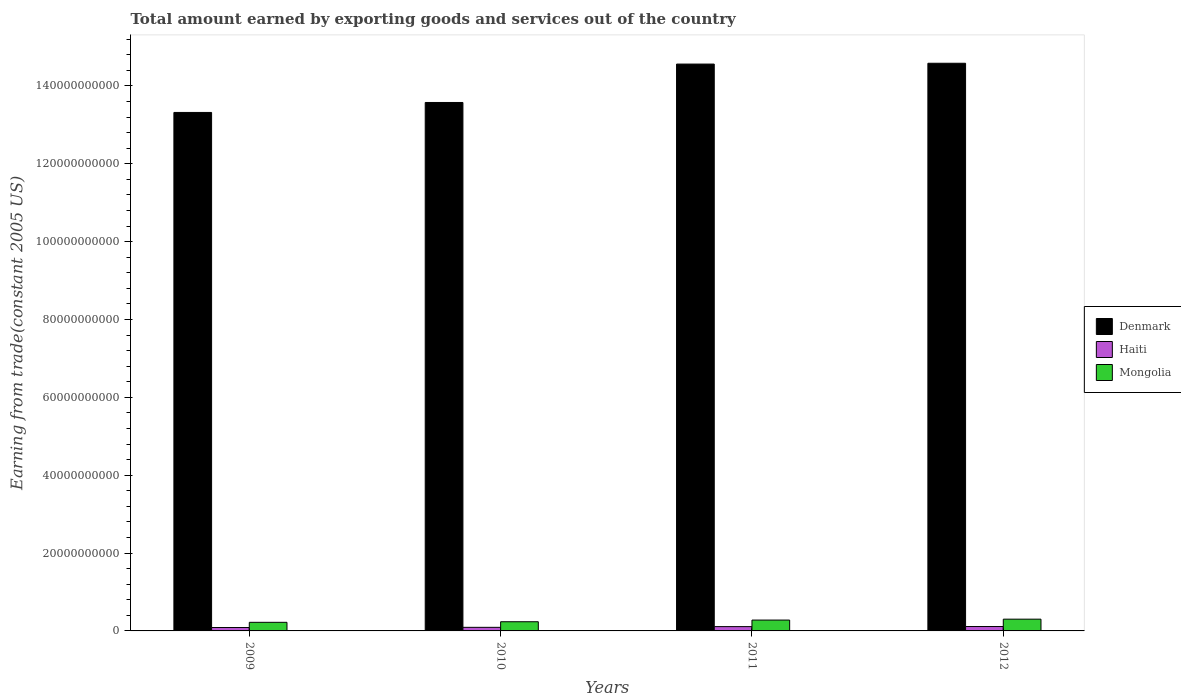How many different coloured bars are there?
Your answer should be compact. 3. Are the number of bars on each tick of the X-axis equal?
Your response must be concise. Yes. How many bars are there on the 4th tick from the right?
Keep it short and to the point. 3. What is the total amount earned by exporting goods and services in Denmark in 2012?
Keep it short and to the point. 1.46e+11. Across all years, what is the maximum total amount earned by exporting goods and services in Mongolia?
Offer a very short reply. 3.02e+09. Across all years, what is the minimum total amount earned by exporting goods and services in Mongolia?
Provide a succinct answer. 2.21e+09. What is the total total amount earned by exporting goods and services in Mongolia in the graph?
Ensure brevity in your answer.  1.04e+1. What is the difference between the total amount earned by exporting goods and services in Haiti in 2010 and that in 2012?
Make the answer very short. -2.10e+08. What is the difference between the total amount earned by exporting goods and services in Mongolia in 2011 and the total amount earned by exporting goods and services in Denmark in 2010?
Keep it short and to the point. -1.33e+11. What is the average total amount earned by exporting goods and services in Mongolia per year?
Make the answer very short. 2.59e+09. In the year 2012, what is the difference between the total amount earned by exporting goods and services in Denmark and total amount earned by exporting goods and services in Haiti?
Keep it short and to the point. 1.45e+11. What is the ratio of the total amount earned by exporting goods and services in Denmark in 2010 to that in 2012?
Your answer should be compact. 0.93. What is the difference between the highest and the second highest total amount earned by exporting goods and services in Haiti?
Your answer should be compact. 2.32e+07. What is the difference between the highest and the lowest total amount earned by exporting goods and services in Haiti?
Your response must be concise. 2.55e+08. What does the 2nd bar from the left in 2009 represents?
Make the answer very short. Haiti. What does the 2nd bar from the right in 2010 represents?
Your answer should be very brief. Haiti. Is it the case that in every year, the sum of the total amount earned by exporting goods and services in Denmark and total amount earned by exporting goods and services in Mongolia is greater than the total amount earned by exporting goods and services in Haiti?
Your answer should be compact. Yes. What is the difference between two consecutive major ticks on the Y-axis?
Ensure brevity in your answer.  2.00e+1. Are the values on the major ticks of Y-axis written in scientific E-notation?
Give a very brief answer. No. How many legend labels are there?
Make the answer very short. 3. How are the legend labels stacked?
Offer a very short reply. Vertical. What is the title of the graph?
Offer a very short reply. Total amount earned by exporting goods and services out of the country. Does "Paraguay" appear as one of the legend labels in the graph?
Your answer should be very brief. No. What is the label or title of the Y-axis?
Ensure brevity in your answer.  Earning from trade(constant 2005 US). What is the Earning from trade(constant 2005 US) in Denmark in 2009?
Your answer should be very brief. 1.33e+11. What is the Earning from trade(constant 2005 US) in Haiti in 2009?
Provide a succinct answer. 8.75e+08. What is the Earning from trade(constant 2005 US) of Mongolia in 2009?
Your response must be concise. 2.21e+09. What is the Earning from trade(constant 2005 US) in Denmark in 2010?
Provide a short and direct response. 1.36e+11. What is the Earning from trade(constant 2005 US) in Haiti in 2010?
Ensure brevity in your answer.  9.20e+08. What is the Earning from trade(constant 2005 US) in Mongolia in 2010?
Your answer should be compact. 2.36e+09. What is the Earning from trade(constant 2005 US) in Denmark in 2011?
Your answer should be compact. 1.46e+11. What is the Earning from trade(constant 2005 US) of Haiti in 2011?
Provide a short and direct response. 1.11e+09. What is the Earning from trade(constant 2005 US) in Mongolia in 2011?
Offer a very short reply. 2.79e+09. What is the Earning from trade(constant 2005 US) in Denmark in 2012?
Give a very brief answer. 1.46e+11. What is the Earning from trade(constant 2005 US) in Haiti in 2012?
Keep it short and to the point. 1.13e+09. What is the Earning from trade(constant 2005 US) of Mongolia in 2012?
Provide a succinct answer. 3.02e+09. Across all years, what is the maximum Earning from trade(constant 2005 US) of Denmark?
Offer a terse response. 1.46e+11. Across all years, what is the maximum Earning from trade(constant 2005 US) of Haiti?
Give a very brief answer. 1.13e+09. Across all years, what is the maximum Earning from trade(constant 2005 US) of Mongolia?
Provide a short and direct response. 3.02e+09. Across all years, what is the minimum Earning from trade(constant 2005 US) in Denmark?
Offer a terse response. 1.33e+11. Across all years, what is the minimum Earning from trade(constant 2005 US) of Haiti?
Your answer should be compact. 8.75e+08. Across all years, what is the minimum Earning from trade(constant 2005 US) in Mongolia?
Provide a short and direct response. 2.21e+09. What is the total Earning from trade(constant 2005 US) of Denmark in the graph?
Provide a short and direct response. 5.60e+11. What is the total Earning from trade(constant 2005 US) in Haiti in the graph?
Offer a terse response. 4.03e+09. What is the total Earning from trade(constant 2005 US) of Mongolia in the graph?
Offer a very short reply. 1.04e+1. What is the difference between the Earning from trade(constant 2005 US) of Denmark in 2009 and that in 2010?
Give a very brief answer. -2.56e+09. What is the difference between the Earning from trade(constant 2005 US) of Haiti in 2009 and that in 2010?
Your response must be concise. -4.49e+07. What is the difference between the Earning from trade(constant 2005 US) in Mongolia in 2009 and that in 2010?
Offer a terse response. -1.49e+08. What is the difference between the Earning from trade(constant 2005 US) in Denmark in 2009 and that in 2011?
Ensure brevity in your answer.  -1.24e+1. What is the difference between the Earning from trade(constant 2005 US) of Haiti in 2009 and that in 2011?
Offer a very short reply. -2.32e+08. What is the difference between the Earning from trade(constant 2005 US) of Mongolia in 2009 and that in 2011?
Ensure brevity in your answer.  -5.79e+08. What is the difference between the Earning from trade(constant 2005 US) of Denmark in 2009 and that in 2012?
Your answer should be very brief. -1.26e+1. What is the difference between the Earning from trade(constant 2005 US) of Haiti in 2009 and that in 2012?
Your answer should be compact. -2.55e+08. What is the difference between the Earning from trade(constant 2005 US) in Mongolia in 2009 and that in 2012?
Ensure brevity in your answer.  -8.10e+08. What is the difference between the Earning from trade(constant 2005 US) of Denmark in 2010 and that in 2011?
Keep it short and to the point. -9.87e+09. What is the difference between the Earning from trade(constant 2005 US) in Haiti in 2010 and that in 2011?
Offer a terse response. -1.87e+08. What is the difference between the Earning from trade(constant 2005 US) in Mongolia in 2010 and that in 2011?
Offer a terse response. -4.30e+08. What is the difference between the Earning from trade(constant 2005 US) of Denmark in 2010 and that in 2012?
Your response must be concise. -1.01e+1. What is the difference between the Earning from trade(constant 2005 US) in Haiti in 2010 and that in 2012?
Give a very brief answer. -2.10e+08. What is the difference between the Earning from trade(constant 2005 US) of Mongolia in 2010 and that in 2012?
Ensure brevity in your answer.  -6.61e+08. What is the difference between the Earning from trade(constant 2005 US) in Denmark in 2011 and that in 2012?
Give a very brief answer. -2.08e+08. What is the difference between the Earning from trade(constant 2005 US) in Haiti in 2011 and that in 2012?
Your answer should be very brief. -2.32e+07. What is the difference between the Earning from trade(constant 2005 US) of Mongolia in 2011 and that in 2012?
Your answer should be very brief. -2.31e+08. What is the difference between the Earning from trade(constant 2005 US) of Denmark in 2009 and the Earning from trade(constant 2005 US) of Haiti in 2010?
Provide a short and direct response. 1.32e+11. What is the difference between the Earning from trade(constant 2005 US) in Denmark in 2009 and the Earning from trade(constant 2005 US) in Mongolia in 2010?
Offer a very short reply. 1.31e+11. What is the difference between the Earning from trade(constant 2005 US) of Haiti in 2009 and the Earning from trade(constant 2005 US) of Mongolia in 2010?
Ensure brevity in your answer.  -1.48e+09. What is the difference between the Earning from trade(constant 2005 US) of Denmark in 2009 and the Earning from trade(constant 2005 US) of Haiti in 2011?
Keep it short and to the point. 1.32e+11. What is the difference between the Earning from trade(constant 2005 US) of Denmark in 2009 and the Earning from trade(constant 2005 US) of Mongolia in 2011?
Give a very brief answer. 1.30e+11. What is the difference between the Earning from trade(constant 2005 US) of Haiti in 2009 and the Earning from trade(constant 2005 US) of Mongolia in 2011?
Keep it short and to the point. -1.91e+09. What is the difference between the Earning from trade(constant 2005 US) of Denmark in 2009 and the Earning from trade(constant 2005 US) of Haiti in 2012?
Make the answer very short. 1.32e+11. What is the difference between the Earning from trade(constant 2005 US) in Denmark in 2009 and the Earning from trade(constant 2005 US) in Mongolia in 2012?
Give a very brief answer. 1.30e+11. What is the difference between the Earning from trade(constant 2005 US) in Haiti in 2009 and the Earning from trade(constant 2005 US) in Mongolia in 2012?
Provide a short and direct response. -2.14e+09. What is the difference between the Earning from trade(constant 2005 US) of Denmark in 2010 and the Earning from trade(constant 2005 US) of Haiti in 2011?
Offer a terse response. 1.35e+11. What is the difference between the Earning from trade(constant 2005 US) in Denmark in 2010 and the Earning from trade(constant 2005 US) in Mongolia in 2011?
Give a very brief answer. 1.33e+11. What is the difference between the Earning from trade(constant 2005 US) of Haiti in 2010 and the Earning from trade(constant 2005 US) of Mongolia in 2011?
Provide a short and direct response. -1.87e+09. What is the difference between the Earning from trade(constant 2005 US) in Denmark in 2010 and the Earning from trade(constant 2005 US) in Haiti in 2012?
Make the answer very short. 1.35e+11. What is the difference between the Earning from trade(constant 2005 US) of Denmark in 2010 and the Earning from trade(constant 2005 US) of Mongolia in 2012?
Your answer should be very brief. 1.33e+11. What is the difference between the Earning from trade(constant 2005 US) of Haiti in 2010 and the Earning from trade(constant 2005 US) of Mongolia in 2012?
Make the answer very short. -2.10e+09. What is the difference between the Earning from trade(constant 2005 US) in Denmark in 2011 and the Earning from trade(constant 2005 US) in Haiti in 2012?
Offer a very short reply. 1.44e+11. What is the difference between the Earning from trade(constant 2005 US) of Denmark in 2011 and the Earning from trade(constant 2005 US) of Mongolia in 2012?
Give a very brief answer. 1.43e+11. What is the difference between the Earning from trade(constant 2005 US) in Haiti in 2011 and the Earning from trade(constant 2005 US) in Mongolia in 2012?
Your response must be concise. -1.91e+09. What is the average Earning from trade(constant 2005 US) in Denmark per year?
Ensure brevity in your answer.  1.40e+11. What is the average Earning from trade(constant 2005 US) in Haiti per year?
Offer a terse response. 1.01e+09. What is the average Earning from trade(constant 2005 US) of Mongolia per year?
Make the answer very short. 2.59e+09. In the year 2009, what is the difference between the Earning from trade(constant 2005 US) of Denmark and Earning from trade(constant 2005 US) of Haiti?
Your answer should be compact. 1.32e+11. In the year 2009, what is the difference between the Earning from trade(constant 2005 US) in Denmark and Earning from trade(constant 2005 US) in Mongolia?
Your answer should be compact. 1.31e+11. In the year 2009, what is the difference between the Earning from trade(constant 2005 US) in Haiti and Earning from trade(constant 2005 US) in Mongolia?
Make the answer very short. -1.33e+09. In the year 2010, what is the difference between the Earning from trade(constant 2005 US) of Denmark and Earning from trade(constant 2005 US) of Haiti?
Give a very brief answer. 1.35e+11. In the year 2010, what is the difference between the Earning from trade(constant 2005 US) of Denmark and Earning from trade(constant 2005 US) of Mongolia?
Keep it short and to the point. 1.33e+11. In the year 2010, what is the difference between the Earning from trade(constant 2005 US) in Haiti and Earning from trade(constant 2005 US) in Mongolia?
Offer a very short reply. -1.44e+09. In the year 2011, what is the difference between the Earning from trade(constant 2005 US) in Denmark and Earning from trade(constant 2005 US) in Haiti?
Keep it short and to the point. 1.44e+11. In the year 2011, what is the difference between the Earning from trade(constant 2005 US) of Denmark and Earning from trade(constant 2005 US) of Mongolia?
Give a very brief answer. 1.43e+11. In the year 2011, what is the difference between the Earning from trade(constant 2005 US) in Haiti and Earning from trade(constant 2005 US) in Mongolia?
Your answer should be very brief. -1.68e+09. In the year 2012, what is the difference between the Earning from trade(constant 2005 US) in Denmark and Earning from trade(constant 2005 US) in Haiti?
Ensure brevity in your answer.  1.45e+11. In the year 2012, what is the difference between the Earning from trade(constant 2005 US) of Denmark and Earning from trade(constant 2005 US) of Mongolia?
Give a very brief answer. 1.43e+11. In the year 2012, what is the difference between the Earning from trade(constant 2005 US) in Haiti and Earning from trade(constant 2005 US) in Mongolia?
Your answer should be compact. -1.89e+09. What is the ratio of the Earning from trade(constant 2005 US) of Denmark in 2009 to that in 2010?
Ensure brevity in your answer.  0.98. What is the ratio of the Earning from trade(constant 2005 US) in Haiti in 2009 to that in 2010?
Give a very brief answer. 0.95. What is the ratio of the Earning from trade(constant 2005 US) in Mongolia in 2009 to that in 2010?
Offer a terse response. 0.94. What is the ratio of the Earning from trade(constant 2005 US) in Denmark in 2009 to that in 2011?
Your answer should be very brief. 0.91. What is the ratio of the Earning from trade(constant 2005 US) in Haiti in 2009 to that in 2011?
Keep it short and to the point. 0.79. What is the ratio of the Earning from trade(constant 2005 US) of Mongolia in 2009 to that in 2011?
Offer a terse response. 0.79. What is the ratio of the Earning from trade(constant 2005 US) in Denmark in 2009 to that in 2012?
Your answer should be very brief. 0.91. What is the ratio of the Earning from trade(constant 2005 US) in Haiti in 2009 to that in 2012?
Provide a succinct answer. 0.77. What is the ratio of the Earning from trade(constant 2005 US) in Mongolia in 2009 to that in 2012?
Ensure brevity in your answer.  0.73. What is the ratio of the Earning from trade(constant 2005 US) in Denmark in 2010 to that in 2011?
Ensure brevity in your answer.  0.93. What is the ratio of the Earning from trade(constant 2005 US) of Haiti in 2010 to that in 2011?
Ensure brevity in your answer.  0.83. What is the ratio of the Earning from trade(constant 2005 US) of Mongolia in 2010 to that in 2011?
Give a very brief answer. 0.85. What is the ratio of the Earning from trade(constant 2005 US) of Denmark in 2010 to that in 2012?
Your answer should be very brief. 0.93. What is the ratio of the Earning from trade(constant 2005 US) of Haiti in 2010 to that in 2012?
Keep it short and to the point. 0.81. What is the ratio of the Earning from trade(constant 2005 US) in Mongolia in 2010 to that in 2012?
Your response must be concise. 0.78. What is the ratio of the Earning from trade(constant 2005 US) in Denmark in 2011 to that in 2012?
Your answer should be compact. 1. What is the ratio of the Earning from trade(constant 2005 US) of Haiti in 2011 to that in 2012?
Keep it short and to the point. 0.98. What is the ratio of the Earning from trade(constant 2005 US) in Mongolia in 2011 to that in 2012?
Your answer should be very brief. 0.92. What is the difference between the highest and the second highest Earning from trade(constant 2005 US) in Denmark?
Offer a very short reply. 2.08e+08. What is the difference between the highest and the second highest Earning from trade(constant 2005 US) of Haiti?
Your answer should be very brief. 2.32e+07. What is the difference between the highest and the second highest Earning from trade(constant 2005 US) in Mongolia?
Ensure brevity in your answer.  2.31e+08. What is the difference between the highest and the lowest Earning from trade(constant 2005 US) in Denmark?
Your answer should be compact. 1.26e+1. What is the difference between the highest and the lowest Earning from trade(constant 2005 US) in Haiti?
Ensure brevity in your answer.  2.55e+08. What is the difference between the highest and the lowest Earning from trade(constant 2005 US) of Mongolia?
Provide a succinct answer. 8.10e+08. 